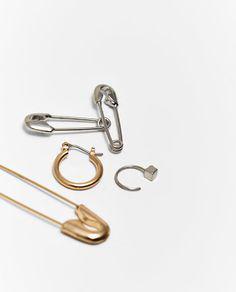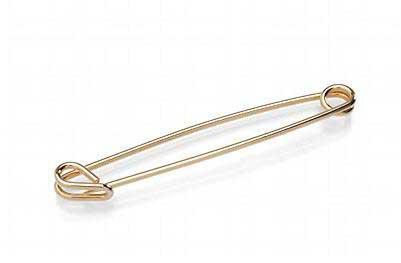The first image is the image on the left, the second image is the image on the right. Evaluate the accuracy of this statement regarding the images: "one of the safety pins is open.". Is it true? Answer yes or no. No. 